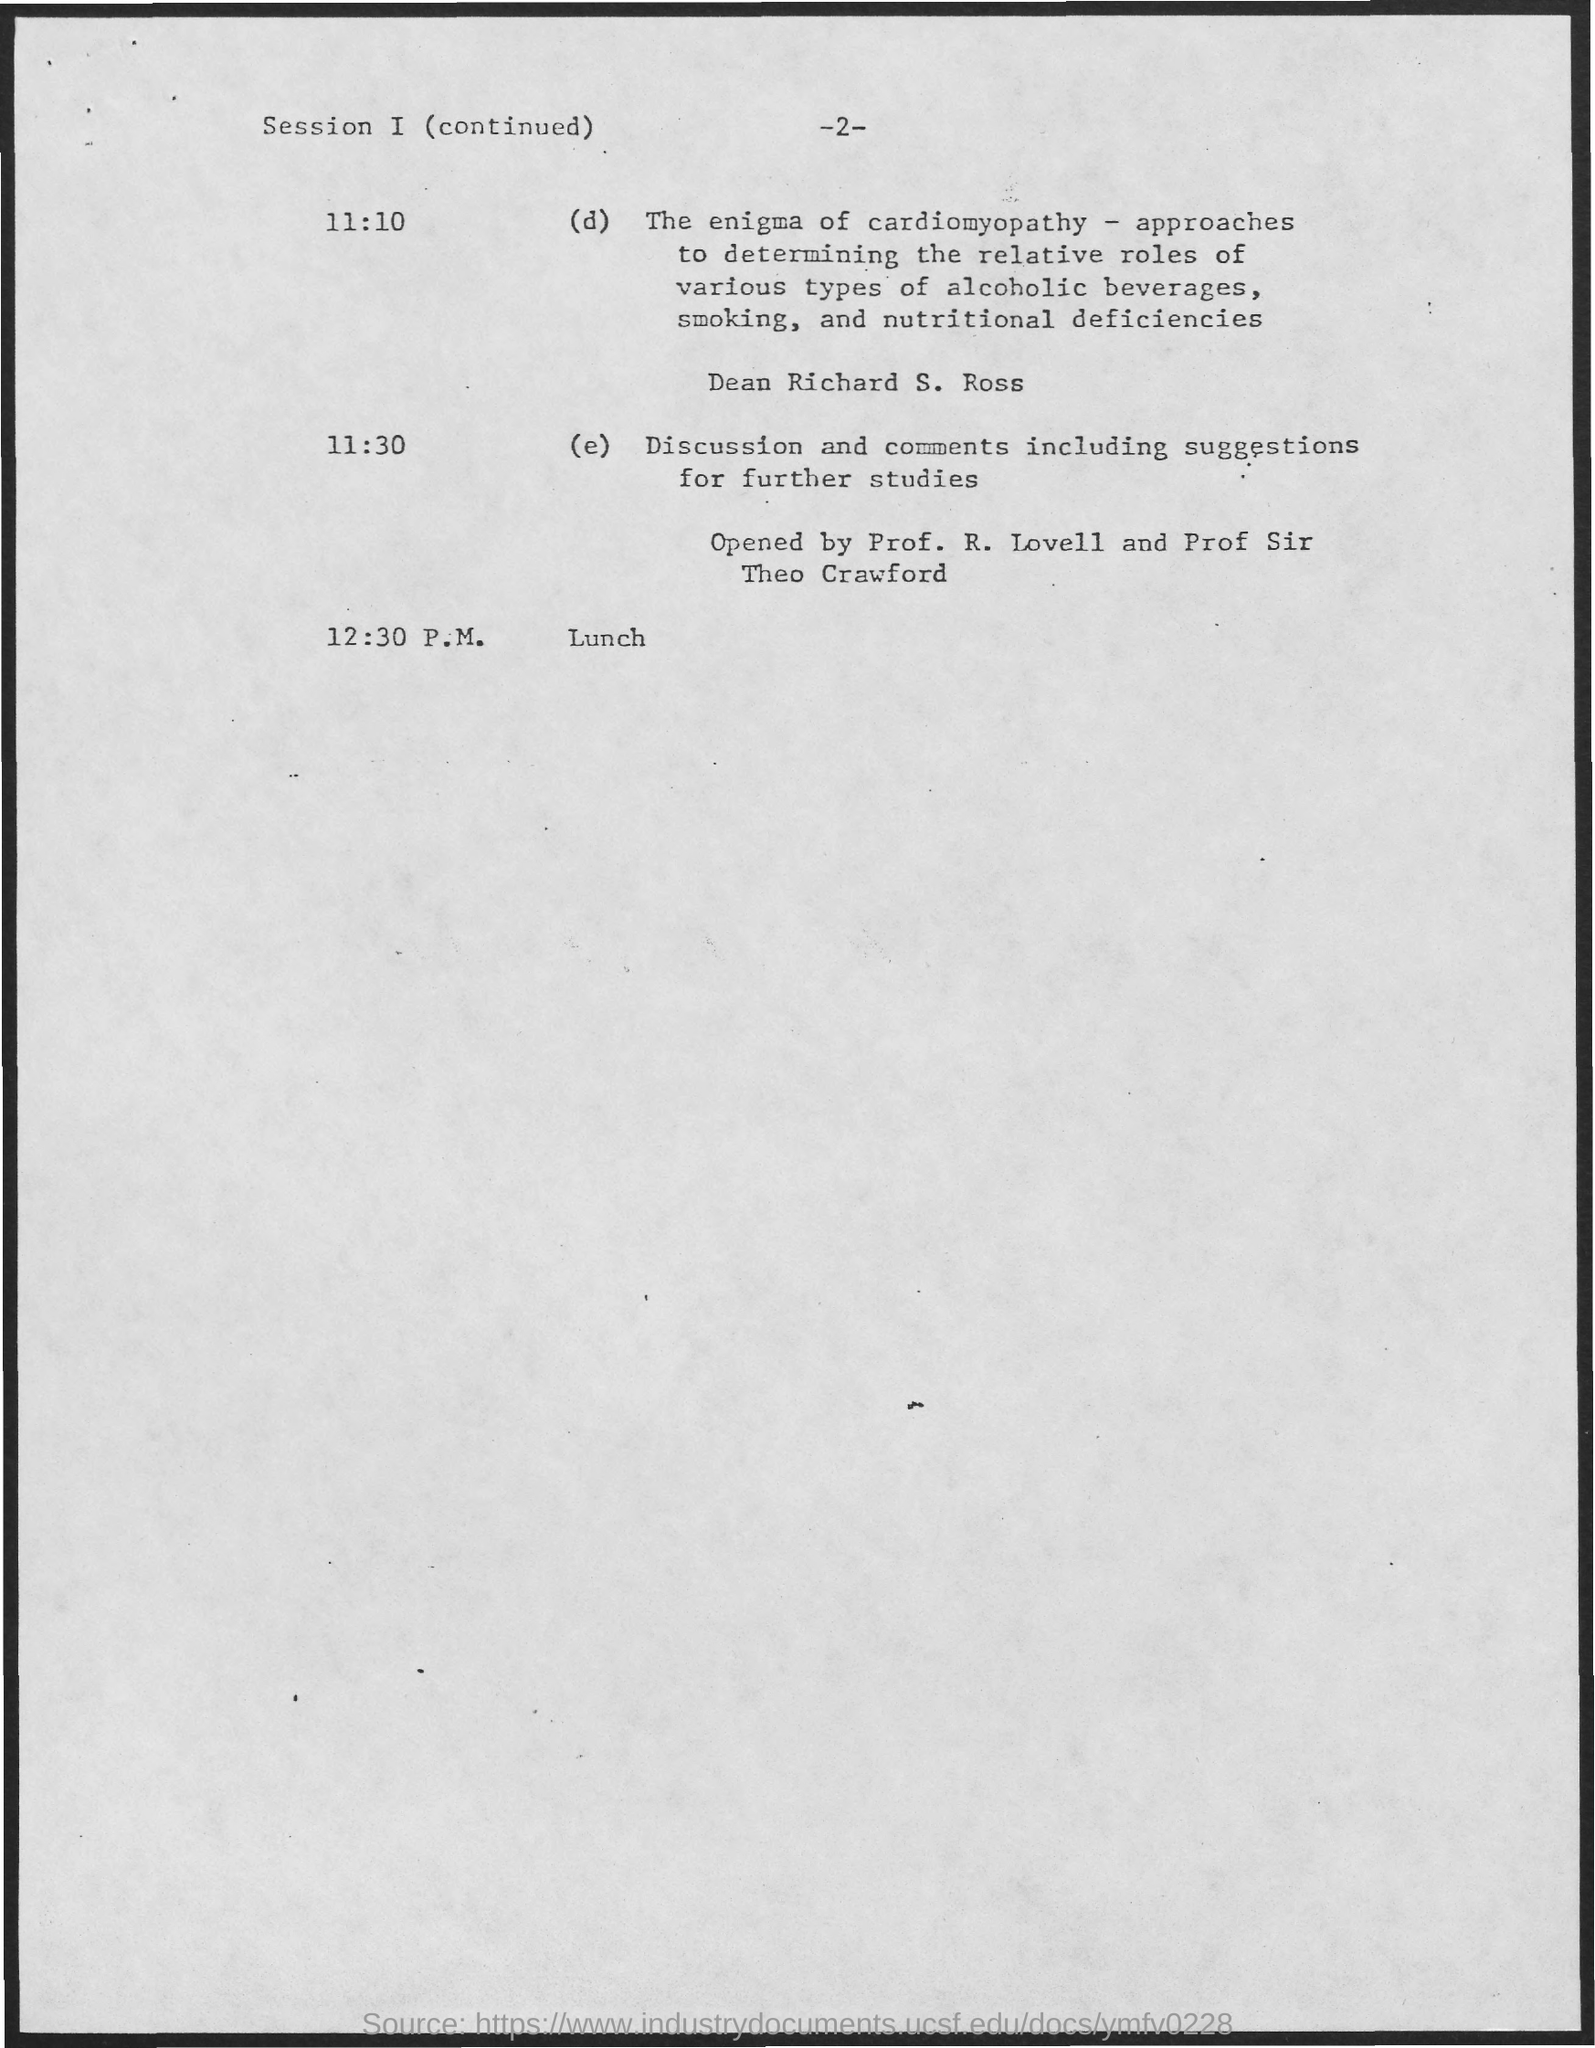When is the Discussion and comments including suggestions for further studies?
Make the answer very short. 11:30. When is the Lunch?
Your answer should be very brief. 12:30 P.M. 